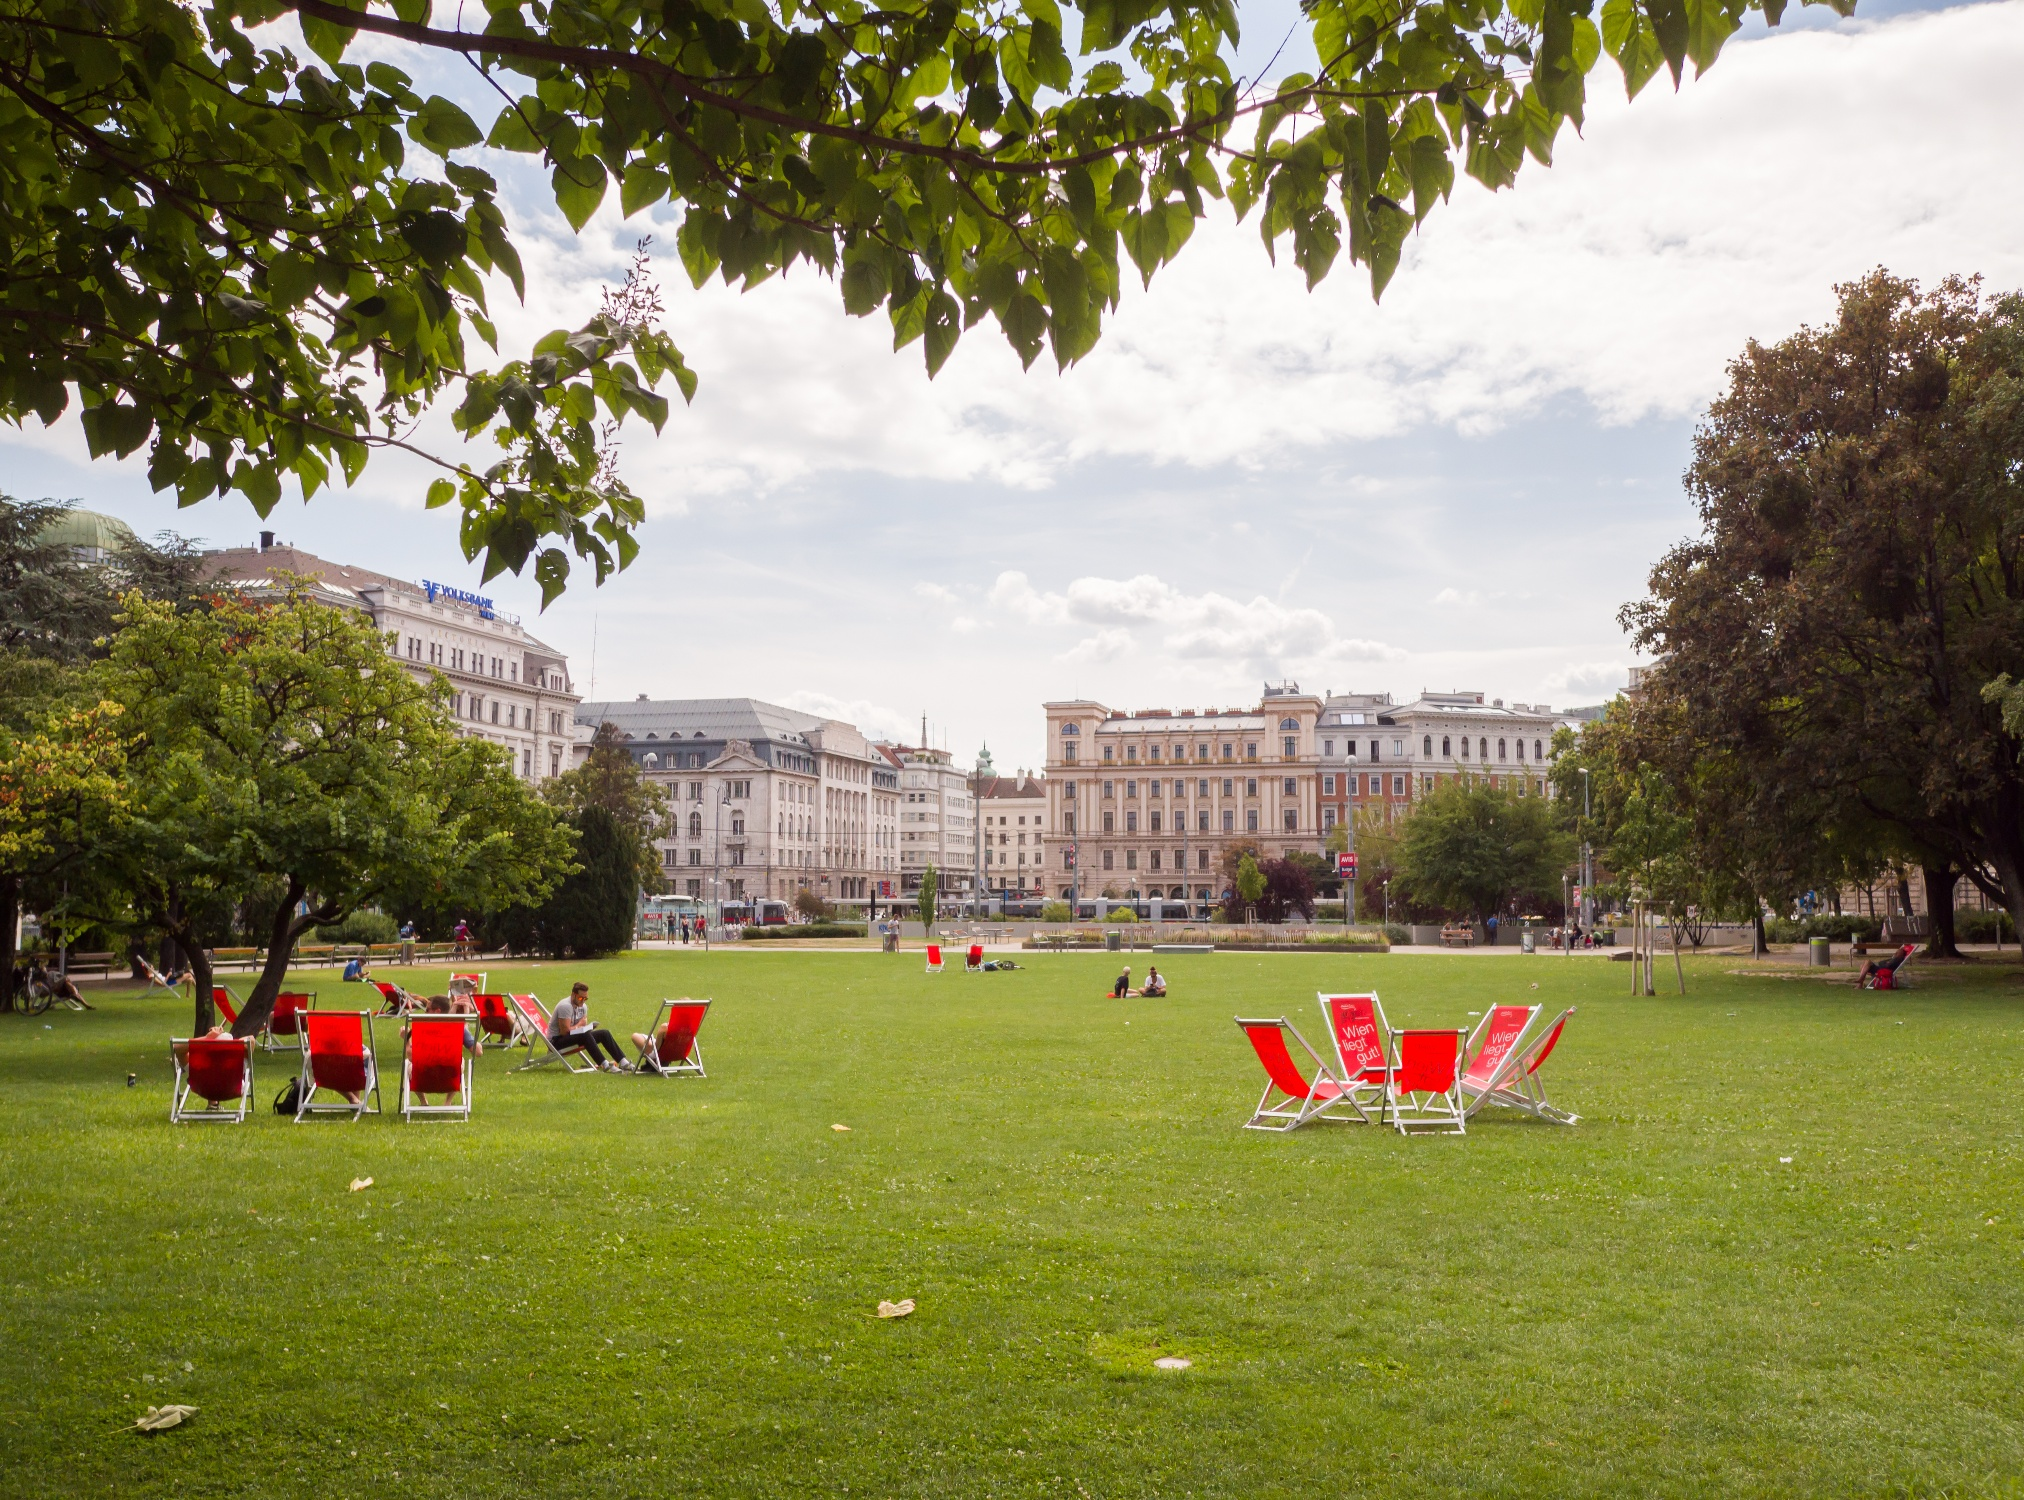What activities do people typically engage in while at this park? Visitors at Jardin Anglais often engage in various leisure activities. They might be found relaxing on the iconic red chairs, enjoying picnics on the grass, or strolling along the pathways. Some may be reading, playing informal games, or simply watching the boats on Lake Geneva. This park provides a tranquil escape from the bustling city life, perfect for relaxation and light recreational activities. 